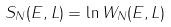Convert formula to latex. <formula><loc_0><loc_0><loc_500><loc_500>S _ { N } ( E , L ) = \ln W _ { N } ( E , L )</formula> 